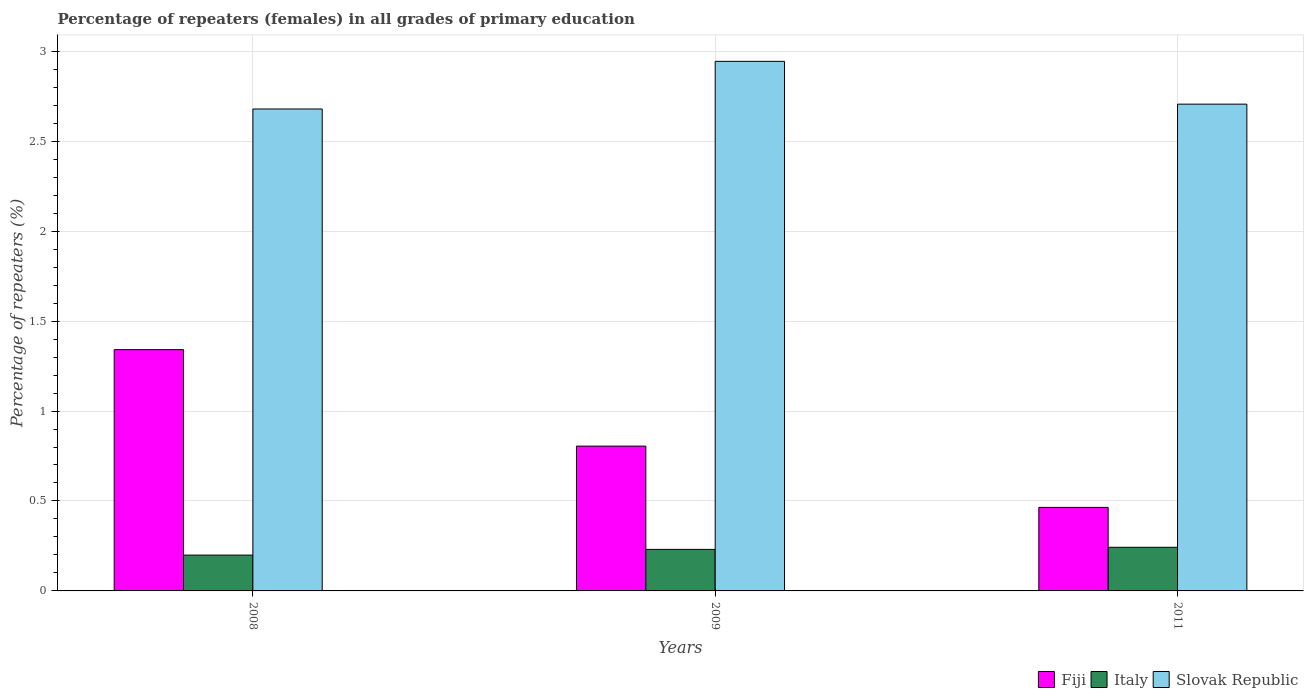How many different coloured bars are there?
Your response must be concise. 3. How many groups of bars are there?
Ensure brevity in your answer.  3. Are the number of bars per tick equal to the number of legend labels?
Ensure brevity in your answer.  Yes. What is the percentage of repeaters (females) in Slovak Republic in 2009?
Give a very brief answer. 2.94. Across all years, what is the maximum percentage of repeaters (females) in Fiji?
Your answer should be very brief. 1.34. Across all years, what is the minimum percentage of repeaters (females) in Slovak Republic?
Your answer should be very brief. 2.68. In which year was the percentage of repeaters (females) in Fiji minimum?
Your answer should be compact. 2011. What is the total percentage of repeaters (females) in Slovak Republic in the graph?
Your response must be concise. 8.33. What is the difference between the percentage of repeaters (females) in Slovak Republic in 2008 and that in 2009?
Keep it short and to the point. -0.26. What is the difference between the percentage of repeaters (females) in Slovak Republic in 2008 and the percentage of repeaters (females) in Fiji in 2011?
Provide a short and direct response. 2.21. What is the average percentage of repeaters (females) in Fiji per year?
Your answer should be compact. 0.87. In the year 2008, what is the difference between the percentage of repeaters (females) in Italy and percentage of repeaters (females) in Slovak Republic?
Offer a very short reply. -2.48. What is the ratio of the percentage of repeaters (females) in Italy in 2008 to that in 2009?
Provide a succinct answer. 0.86. Is the percentage of repeaters (females) in Slovak Republic in 2008 less than that in 2009?
Offer a very short reply. Yes. Is the difference between the percentage of repeaters (females) in Italy in 2008 and 2009 greater than the difference between the percentage of repeaters (females) in Slovak Republic in 2008 and 2009?
Offer a terse response. Yes. What is the difference between the highest and the second highest percentage of repeaters (females) in Fiji?
Provide a succinct answer. 0.54. What is the difference between the highest and the lowest percentage of repeaters (females) in Italy?
Your response must be concise. 0.04. Is the sum of the percentage of repeaters (females) in Fiji in 2008 and 2011 greater than the maximum percentage of repeaters (females) in Italy across all years?
Your response must be concise. Yes. What does the 3rd bar from the right in 2011 represents?
Your response must be concise. Fiji. How many bars are there?
Your response must be concise. 9. Are all the bars in the graph horizontal?
Offer a terse response. No. What is the difference between two consecutive major ticks on the Y-axis?
Make the answer very short. 0.5. Are the values on the major ticks of Y-axis written in scientific E-notation?
Offer a terse response. No. Does the graph contain any zero values?
Provide a succinct answer. No. Where does the legend appear in the graph?
Your response must be concise. Bottom right. How many legend labels are there?
Make the answer very short. 3. What is the title of the graph?
Provide a succinct answer. Percentage of repeaters (females) in all grades of primary education. What is the label or title of the X-axis?
Give a very brief answer. Years. What is the label or title of the Y-axis?
Provide a succinct answer. Percentage of repeaters (%). What is the Percentage of repeaters (%) in Fiji in 2008?
Offer a terse response. 1.34. What is the Percentage of repeaters (%) in Italy in 2008?
Offer a terse response. 0.2. What is the Percentage of repeaters (%) in Slovak Republic in 2008?
Give a very brief answer. 2.68. What is the Percentage of repeaters (%) in Fiji in 2009?
Provide a succinct answer. 0.8. What is the Percentage of repeaters (%) in Italy in 2009?
Provide a succinct answer. 0.23. What is the Percentage of repeaters (%) of Slovak Republic in 2009?
Provide a succinct answer. 2.94. What is the Percentage of repeaters (%) of Fiji in 2011?
Your response must be concise. 0.46. What is the Percentage of repeaters (%) in Italy in 2011?
Offer a terse response. 0.24. What is the Percentage of repeaters (%) in Slovak Republic in 2011?
Provide a succinct answer. 2.71. Across all years, what is the maximum Percentage of repeaters (%) in Fiji?
Your answer should be compact. 1.34. Across all years, what is the maximum Percentage of repeaters (%) of Italy?
Provide a succinct answer. 0.24. Across all years, what is the maximum Percentage of repeaters (%) of Slovak Republic?
Your answer should be compact. 2.94. Across all years, what is the minimum Percentage of repeaters (%) of Fiji?
Ensure brevity in your answer.  0.46. Across all years, what is the minimum Percentage of repeaters (%) of Italy?
Your response must be concise. 0.2. Across all years, what is the minimum Percentage of repeaters (%) of Slovak Republic?
Make the answer very short. 2.68. What is the total Percentage of repeaters (%) of Fiji in the graph?
Offer a very short reply. 2.61. What is the total Percentage of repeaters (%) of Italy in the graph?
Provide a short and direct response. 0.67. What is the total Percentage of repeaters (%) in Slovak Republic in the graph?
Your response must be concise. 8.33. What is the difference between the Percentage of repeaters (%) in Fiji in 2008 and that in 2009?
Provide a short and direct response. 0.54. What is the difference between the Percentage of repeaters (%) in Italy in 2008 and that in 2009?
Your response must be concise. -0.03. What is the difference between the Percentage of repeaters (%) of Slovak Republic in 2008 and that in 2009?
Your answer should be very brief. -0.26. What is the difference between the Percentage of repeaters (%) of Fiji in 2008 and that in 2011?
Your response must be concise. 0.88. What is the difference between the Percentage of repeaters (%) of Italy in 2008 and that in 2011?
Provide a short and direct response. -0.04. What is the difference between the Percentage of repeaters (%) of Slovak Republic in 2008 and that in 2011?
Give a very brief answer. -0.03. What is the difference between the Percentage of repeaters (%) of Fiji in 2009 and that in 2011?
Offer a terse response. 0.34. What is the difference between the Percentage of repeaters (%) in Italy in 2009 and that in 2011?
Offer a very short reply. -0.01. What is the difference between the Percentage of repeaters (%) in Slovak Republic in 2009 and that in 2011?
Provide a succinct answer. 0.24. What is the difference between the Percentage of repeaters (%) in Fiji in 2008 and the Percentage of repeaters (%) in Italy in 2009?
Provide a succinct answer. 1.11. What is the difference between the Percentage of repeaters (%) in Fiji in 2008 and the Percentage of repeaters (%) in Slovak Republic in 2009?
Give a very brief answer. -1.6. What is the difference between the Percentage of repeaters (%) in Italy in 2008 and the Percentage of repeaters (%) in Slovak Republic in 2009?
Your answer should be very brief. -2.74. What is the difference between the Percentage of repeaters (%) of Fiji in 2008 and the Percentage of repeaters (%) of Italy in 2011?
Give a very brief answer. 1.1. What is the difference between the Percentage of repeaters (%) of Fiji in 2008 and the Percentage of repeaters (%) of Slovak Republic in 2011?
Your answer should be very brief. -1.36. What is the difference between the Percentage of repeaters (%) in Italy in 2008 and the Percentage of repeaters (%) in Slovak Republic in 2011?
Make the answer very short. -2.51. What is the difference between the Percentage of repeaters (%) of Fiji in 2009 and the Percentage of repeaters (%) of Italy in 2011?
Keep it short and to the point. 0.56. What is the difference between the Percentage of repeaters (%) in Fiji in 2009 and the Percentage of repeaters (%) in Slovak Republic in 2011?
Provide a succinct answer. -1.9. What is the difference between the Percentage of repeaters (%) in Italy in 2009 and the Percentage of repeaters (%) in Slovak Republic in 2011?
Provide a short and direct response. -2.48. What is the average Percentage of repeaters (%) of Fiji per year?
Give a very brief answer. 0.87. What is the average Percentage of repeaters (%) in Italy per year?
Your answer should be compact. 0.22. What is the average Percentage of repeaters (%) of Slovak Republic per year?
Your response must be concise. 2.78. In the year 2008, what is the difference between the Percentage of repeaters (%) in Fiji and Percentage of repeaters (%) in Italy?
Provide a succinct answer. 1.14. In the year 2008, what is the difference between the Percentage of repeaters (%) of Fiji and Percentage of repeaters (%) of Slovak Republic?
Keep it short and to the point. -1.34. In the year 2008, what is the difference between the Percentage of repeaters (%) of Italy and Percentage of repeaters (%) of Slovak Republic?
Provide a succinct answer. -2.48. In the year 2009, what is the difference between the Percentage of repeaters (%) in Fiji and Percentage of repeaters (%) in Italy?
Provide a short and direct response. 0.57. In the year 2009, what is the difference between the Percentage of repeaters (%) in Fiji and Percentage of repeaters (%) in Slovak Republic?
Your response must be concise. -2.14. In the year 2009, what is the difference between the Percentage of repeaters (%) of Italy and Percentage of repeaters (%) of Slovak Republic?
Ensure brevity in your answer.  -2.71. In the year 2011, what is the difference between the Percentage of repeaters (%) of Fiji and Percentage of repeaters (%) of Italy?
Provide a short and direct response. 0.22. In the year 2011, what is the difference between the Percentage of repeaters (%) of Fiji and Percentage of repeaters (%) of Slovak Republic?
Your response must be concise. -2.24. In the year 2011, what is the difference between the Percentage of repeaters (%) of Italy and Percentage of repeaters (%) of Slovak Republic?
Ensure brevity in your answer.  -2.46. What is the ratio of the Percentage of repeaters (%) of Fiji in 2008 to that in 2009?
Offer a terse response. 1.67. What is the ratio of the Percentage of repeaters (%) in Italy in 2008 to that in 2009?
Your answer should be compact. 0.86. What is the ratio of the Percentage of repeaters (%) in Slovak Republic in 2008 to that in 2009?
Make the answer very short. 0.91. What is the ratio of the Percentage of repeaters (%) of Fiji in 2008 to that in 2011?
Provide a succinct answer. 2.89. What is the ratio of the Percentage of repeaters (%) in Italy in 2008 to that in 2011?
Provide a short and direct response. 0.82. What is the ratio of the Percentage of repeaters (%) in Fiji in 2009 to that in 2011?
Ensure brevity in your answer.  1.73. What is the ratio of the Percentage of repeaters (%) of Italy in 2009 to that in 2011?
Give a very brief answer. 0.95. What is the ratio of the Percentage of repeaters (%) in Slovak Republic in 2009 to that in 2011?
Keep it short and to the point. 1.09. What is the difference between the highest and the second highest Percentage of repeaters (%) of Fiji?
Ensure brevity in your answer.  0.54. What is the difference between the highest and the second highest Percentage of repeaters (%) of Italy?
Ensure brevity in your answer.  0.01. What is the difference between the highest and the second highest Percentage of repeaters (%) in Slovak Republic?
Offer a very short reply. 0.24. What is the difference between the highest and the lowest Percentage of repeaters (%) in Fiji?
Keep it short and to the point. 0.88. What is the difference between the highest and the lowest Percentage of repeaters (%) in Italy?
Your answer should be compact. 0.04. What is the difference between the highest and the lowest Percentage of repeaters (%) of Slovak Republic?
Make the answer very short. 0.26. 